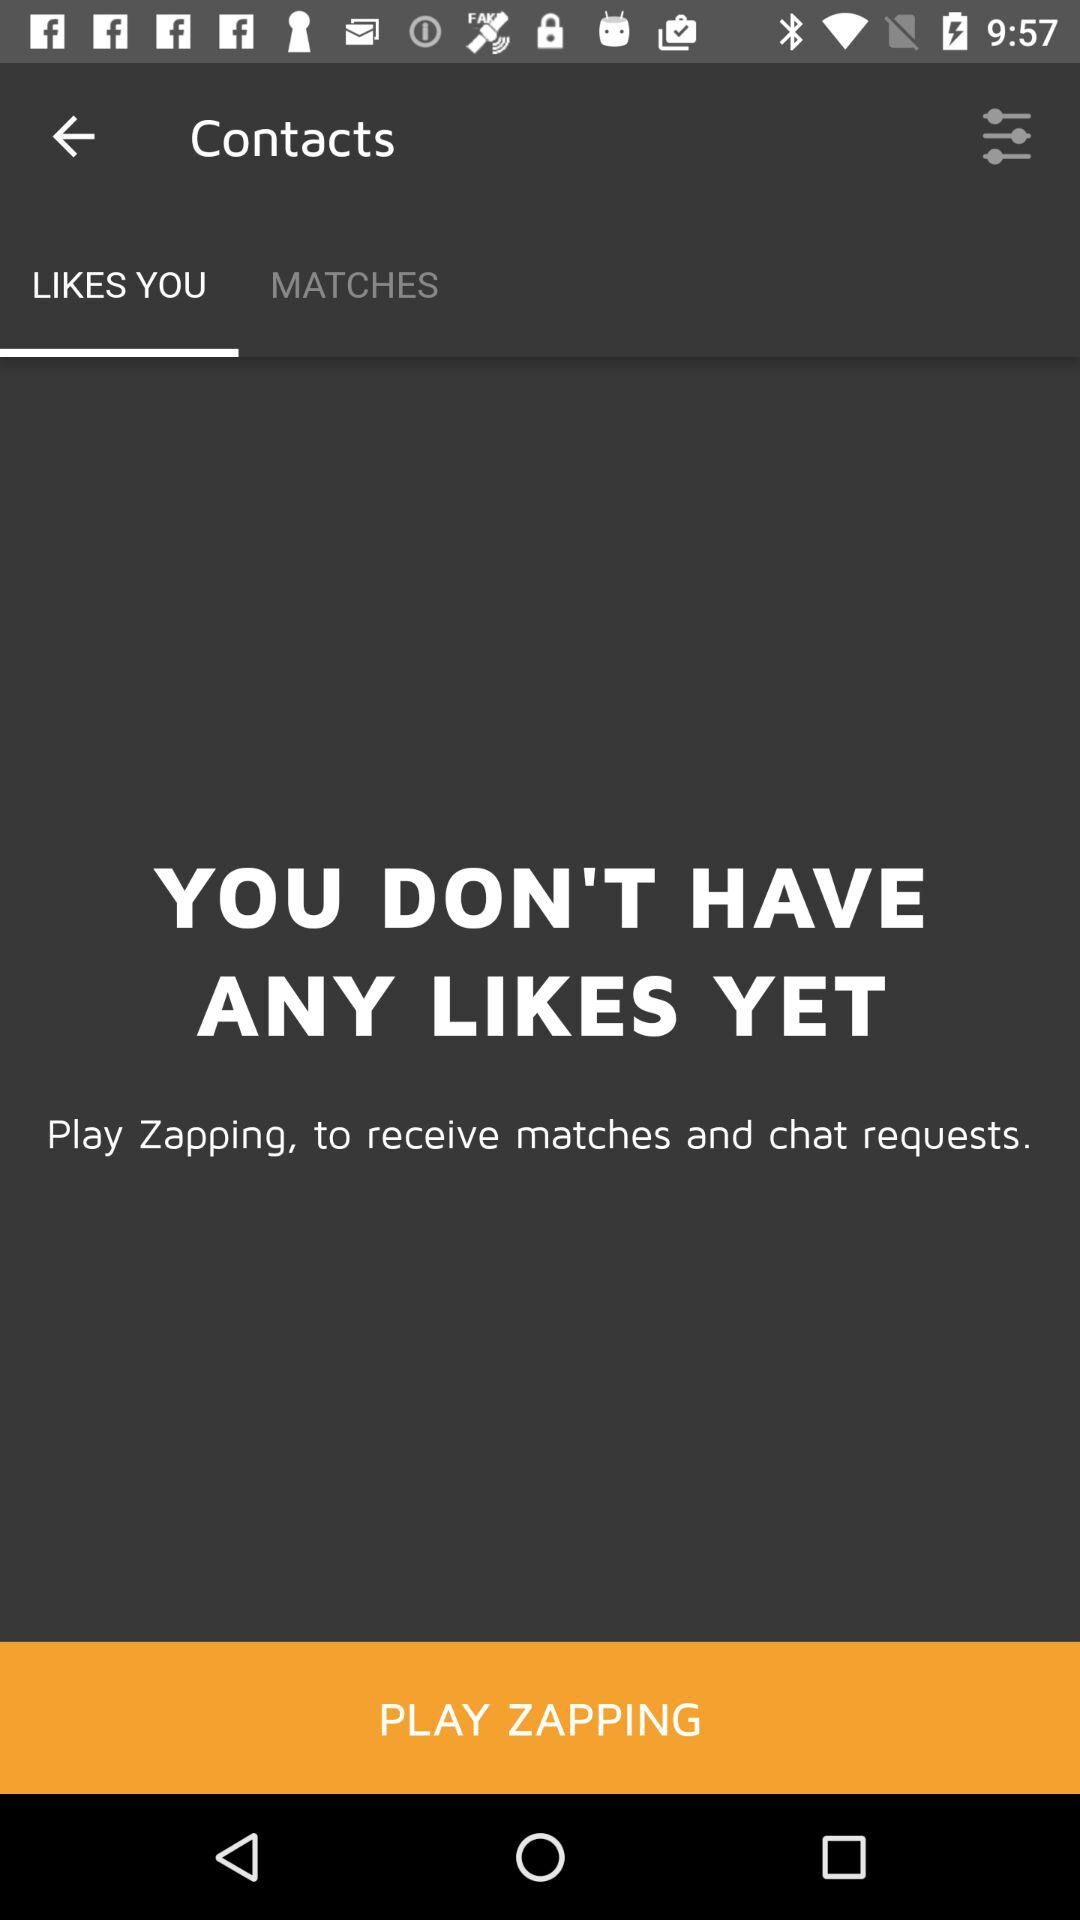Which tab is selected? The selected tab is "LIKES YOU". 